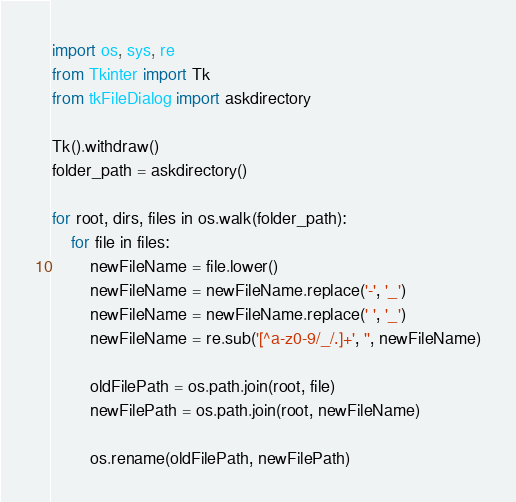<code> <loc_0><loc_0><loc_500><loc_500><_Python_>import os, sys, re
from Tkinter import Tk
from tkFileDialog import askdirectory 

Tk().withdraw()
folder_path = askdirectory()

for root, dirs, files in os.walk(folder_path):
	for file in files:
		newFileName = file.lower()
		newFileName = newFileName.replace('-', '_')
		newFileName = newFileName.replace(' ', '_')
		newFileName = re.sub('[^a-z0-9/_/.]+', '', newFileName)
		
		oldFilePath = os.path.join(root, file)
		newFilePath = os.path.join(root, newFileName)
		
		os.rename(oldFilePath, newFilePath)
</code> 